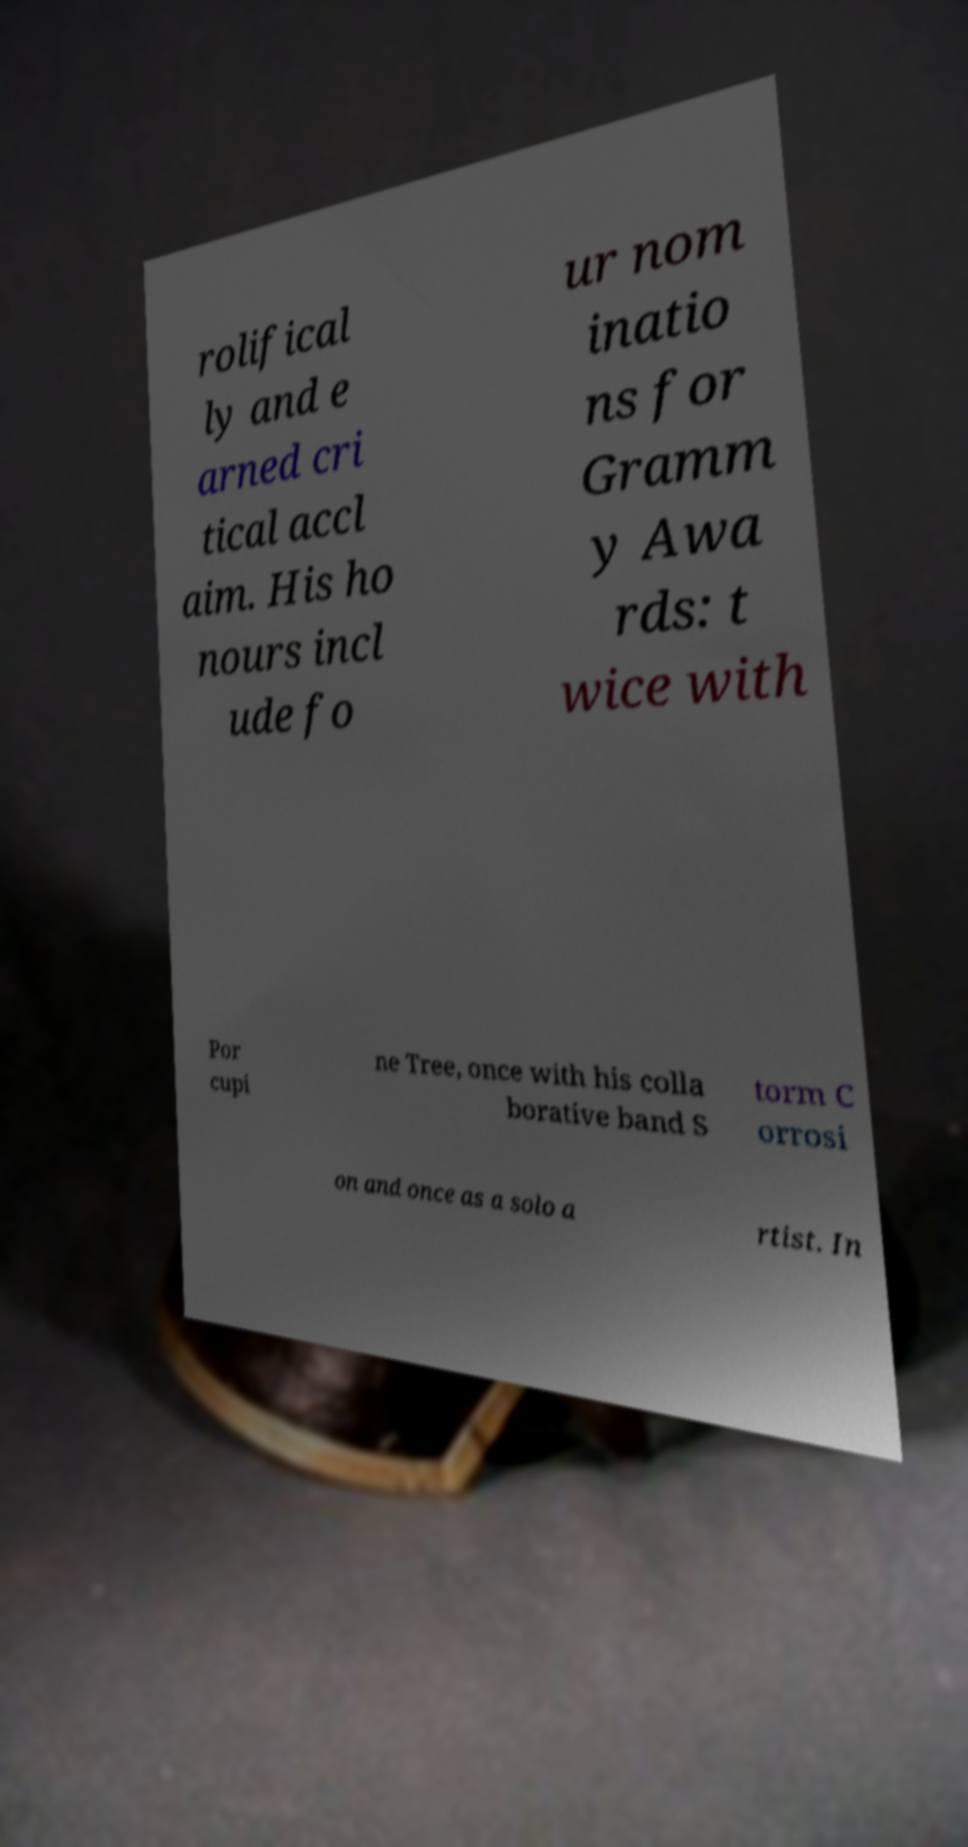There's text embedded in this image that I need extracted. Can you transcribe it verbatim? rolifical ly and e arned cri tical accl aim. His ho nours incl ude fo ur nom inatio ns for Gramm y Awa rds: t wice with Por cupi ne Tree, once with his colla borative band S torm C orrosi on and once as a solo a rtist. In 